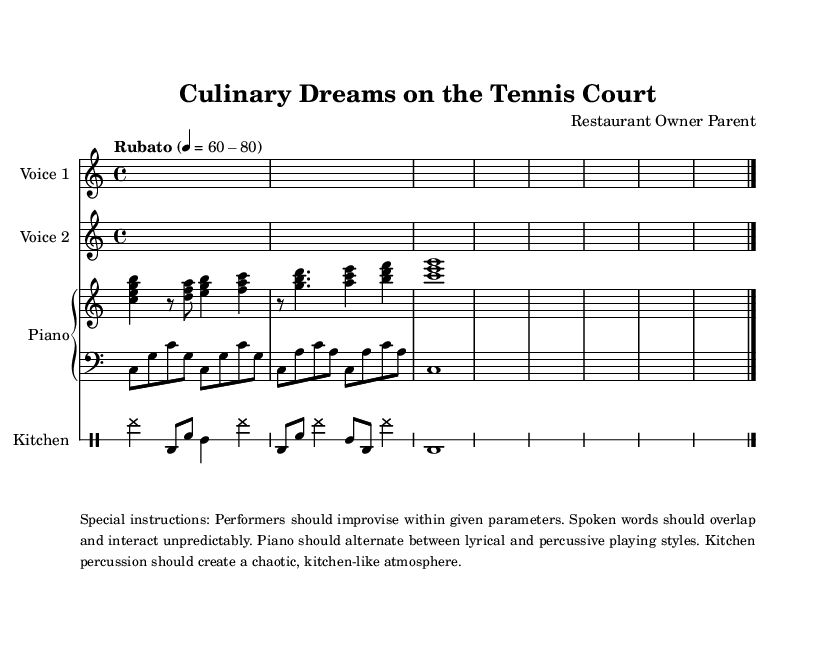What is the time signature of this music? The time signature is written as 4/4, which is indicated immediately at the beginning of the score section.
Answer: 4/4 What is the tempo marking in this music? The tempo marking is "Rubato," which indicates a flexible tempo, and the specific range is given as a quarter note equaling 60-80 beats per minute.
Answer: Rubato How many voices are indicated in the piece? There are two distinct voices indicated within the score, each labeled as Voice 1 and Voice 2, along with additional instrumentation.
Answer: Two What is the primary instrumental focus of this composition? The primary instrumental focus includes a Piano with both a right and left staff, accompanied by a Voice and percussion, simulating a kitchen atmosphere.
Answer: Piano What kind of performance instructions are noted for the musicians? The performance instructions suggest improvisation within specified parameters, emphasizing the unpredictability of spoken words and suggesting varying playing styles for the piano.
Answer: Improvisation What specific elements signify the genre as Experimental? The unique combination of overlapping spoken phrases, chaotic kitchen percussion, and the merging of motivational speeches with restaurant reviews distinctly characterizes the Experimental genre.
Answer: Overlapping spoken phrases 